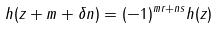<formula> <loc_0><loc_0><loc_500><loc_500>h ( z + m + \delta n ) = ( - 1 ) ^ { m r + n s } h ( z )</formula> 